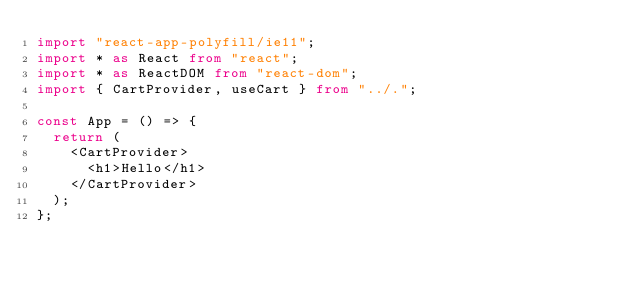Convert code to text. <code><loc_0><loc_0><loc_500><loc_500><_TypeScript_>import "react-app-polyfill/ie11";
import * as React from "react";
import * as ReactDOM from "react-dom";
import { CartProvider, useCart } from "../.";

const App = () => {
  return (
    <CartProvider>
      <h1>Hello</h1>
    </CartProvider>
  );
};
</code> 